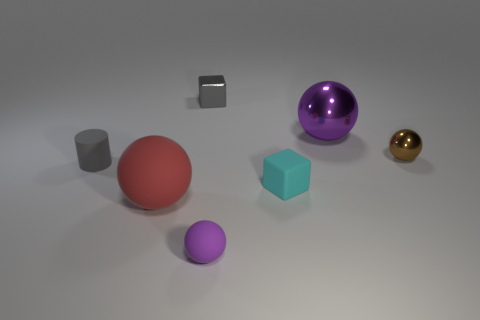Subtract all small purple balls. How many balls are left? 3 Subtract all red balls. How many balls are left? 3 Subtract all green balls. Subtract all blue cylinders. How many balls are left? 4 Add 1 small purple objects. How many objects exist? 8 Subtract all blocks. How many objects are left? 5 Add 4 gray metallic cubes. How many gray metallic cubes are left? 5 Add 1 small cyan blocks. How many small cyan blocks exist? 2 Subtract 0 red cylinders. How many objects are left? 7 Subtract all matte things. Subtract all gray metallic blocks. How many objects are left? 2 